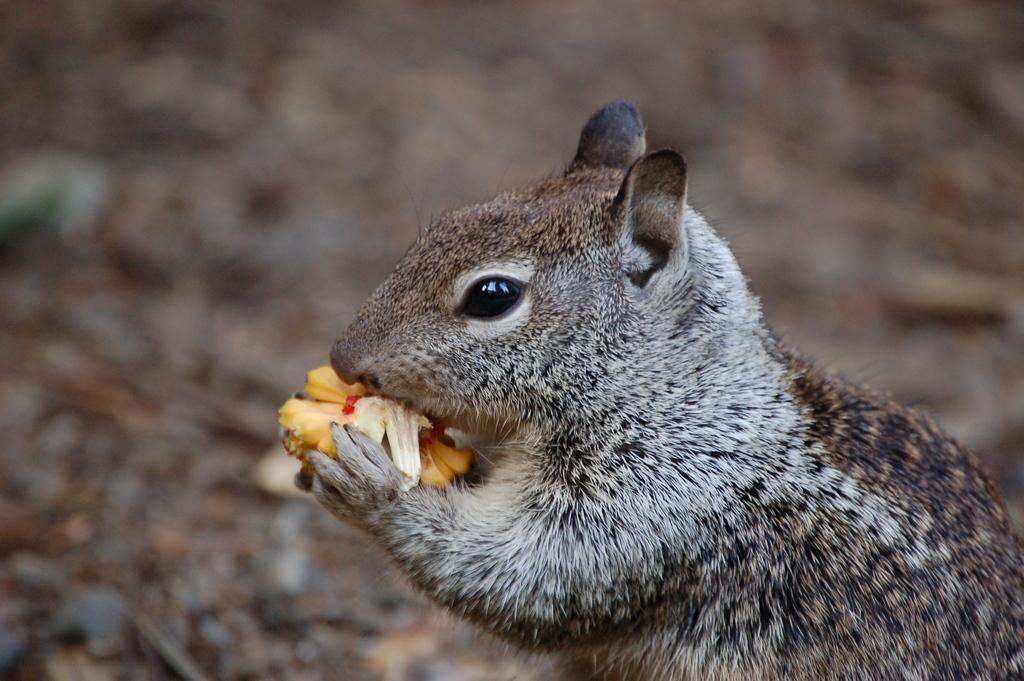How would you summarize this image in a sentence or two? This squirrel is eating a food. Background it is blur. 